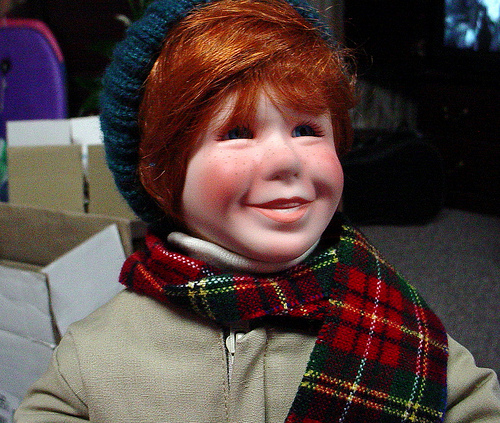<image>
Is there a scarf under the monkey cap? Yes. The scarf is positioned underneath the monkey cap, with the monkey cap above it in the vertical space. Is the boy in front of the box? Yes. The boy is positioned in front of the box, appearing closer to the camera viewpoint. 